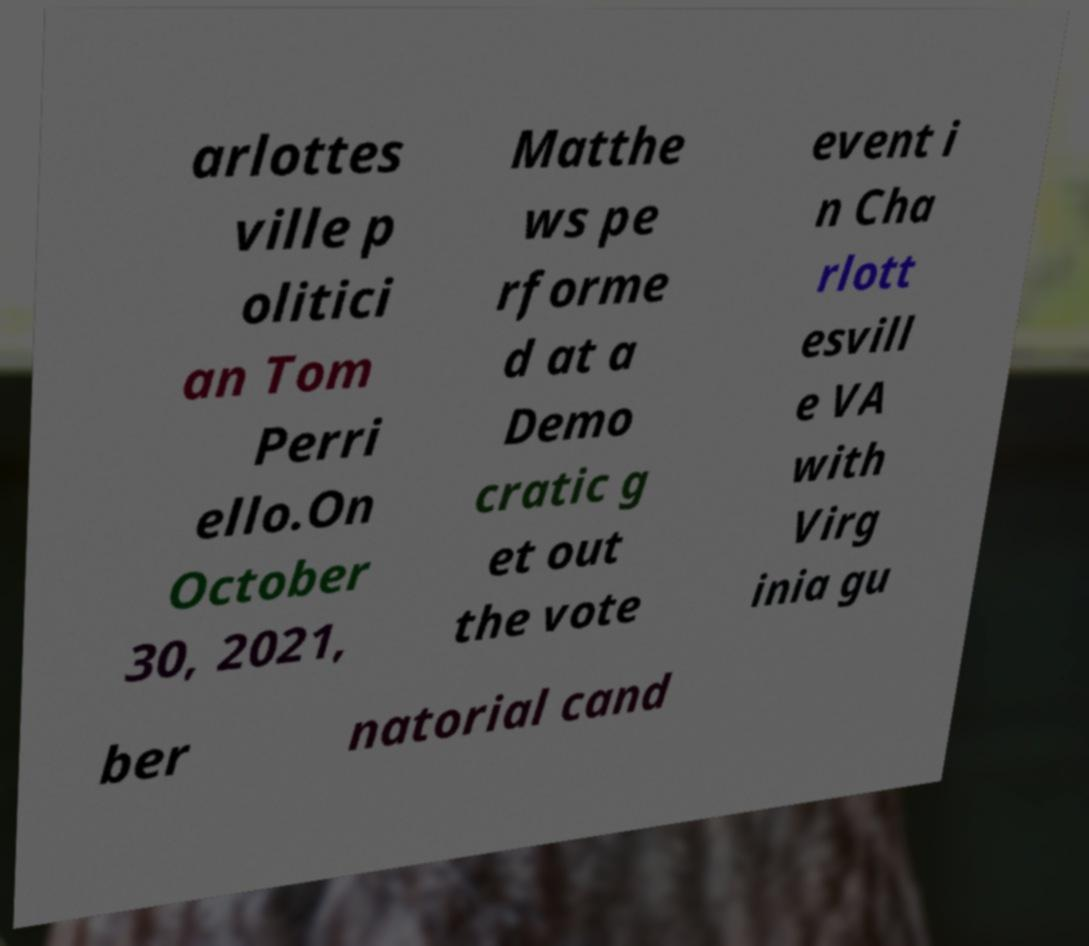Can you read and provide the text displayed in the image?This photo seems to have some interesting text. Can you extract and type it out for me? arlottes ville p olitici an Tom Perri ello.On October 30, 2021, Matthe ws pe rforme d at a Demo cratic g et out the vote event i n Cha rlott esvill e VA with Virg inia gu ber natorial cand 